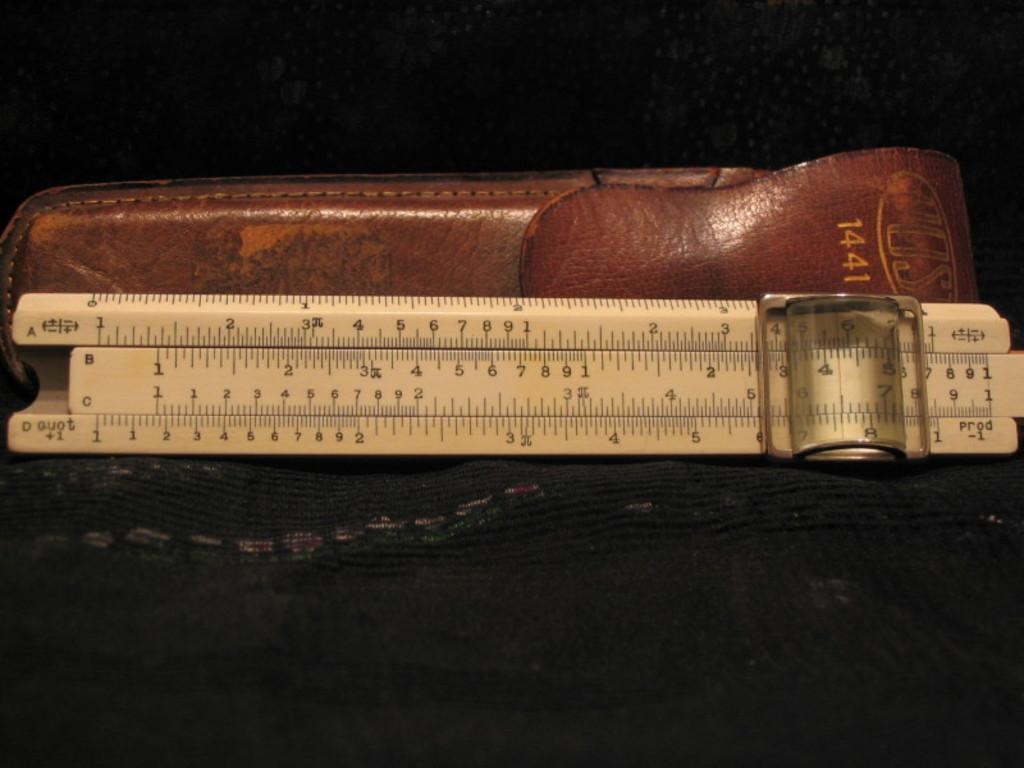<image>
Share a concise interpretation of the image provided. Measuring ruler and a holster of some kind that says 1441 on it. 